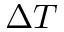<formula> <loc_0><loc_0><loc_500><loc_500>\Delta T</formula> 